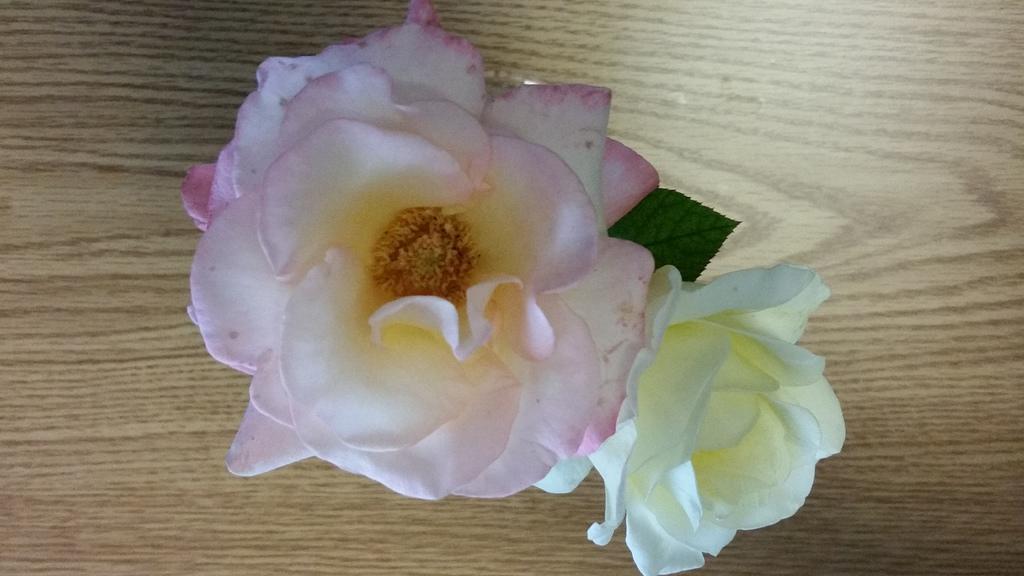Could you give a brief overview of what you see in this image? In this image I can see a pink and white color rose flowers kept on the wooden table. 